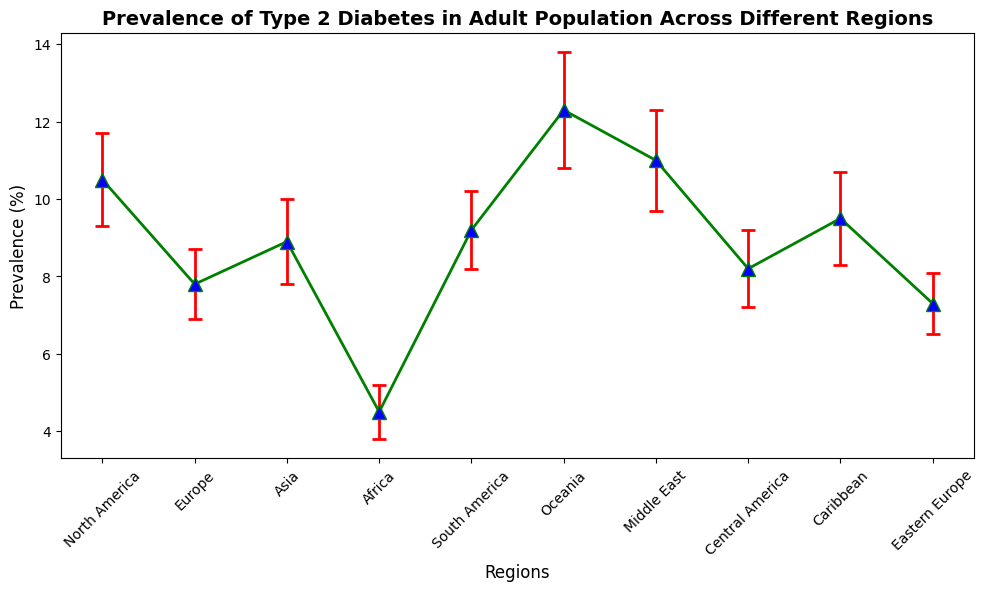Which region has the highest prevalence of Type 2 Diabetes? Look for the region with the highest point on the y-axis representing prevalence. Oceania has the highest point at 12.3%.
Answer: Oceania Which region has the lowest prevalence of Type 2 Diabetes? Check the region with the lowest point on the y-axis. Africa has the lowest prevalence at 4.5%.
Answer: Africa How does the prevalence of Type 2 Diabetes in North America compare to Europe? Compare the heights of the points representing North America and Europe. North America is at 10.5%, which is higher than Europe at 7.8%.
Answer: North America has a higher prevalence than Europe What is the average prevalence of Type 2 Diabetes across all listed regions? Sum the prevalence of all regions and divide by the number of regions. (10.5 + 7.8 + 8.9 + 4.5 + 9.2 + 12.3 + 11.0 + 8.2 + 9.5 + 7.3) / 10 = 8.92%.
Answer: 8.92% Which regions have a prevalence of Type 2 Diabetes greater than 10%? Identify regions where the prevalence point is above 10% on the y-axis. North America, Oceania, and Middle East all have prevalence greater than 10%.
Answer: North America, Oceania, Middle East What is the difference in Type 2 Diabetes prevalence between Oceania and Africa? Subtract Africa's prevalence from Oceania's: 12.3% - 4.5% = 7.8%.
Answer: 7.8% How many regions have a prevalence of Type 2 Diabetes between 8% and 10%? Count the regions with prevalence values between 8% and 10%. Asia (8.9%), South America (9.2%), and Central America (8.2%) fit this range.
Answer: Three regions What is the total error range (upper and lower bounds) for South America? Add and subtract the standard error to South America's prevalence. Upper bound: 9.2% + 1.0% = 10.2%, Lower bound: 9.2% - 1.0% = 8.2%.
Answer: 8.2% to 10.2% Which regions have error bars overlapping the 8% prevalence mark? Check which regions' error bars intersect the 8% prevalence level. Europe (7.8% ± 0.9%) and Central America (8.2% ± 1.0%) have error bars that overlap 8%.
Answer: Europe, Central America 